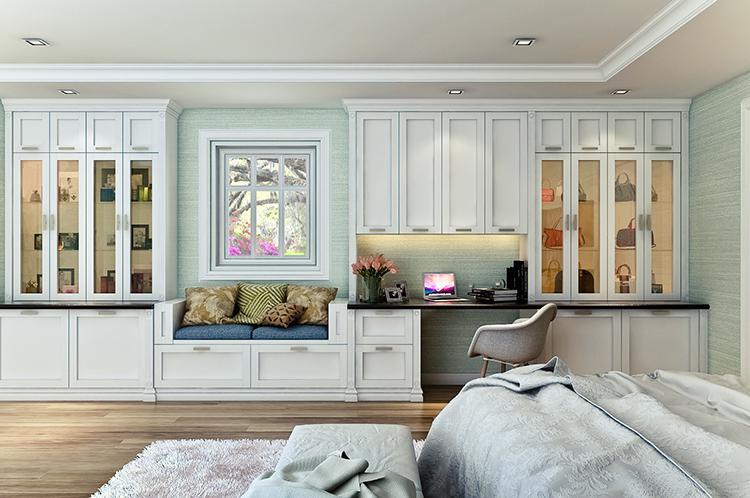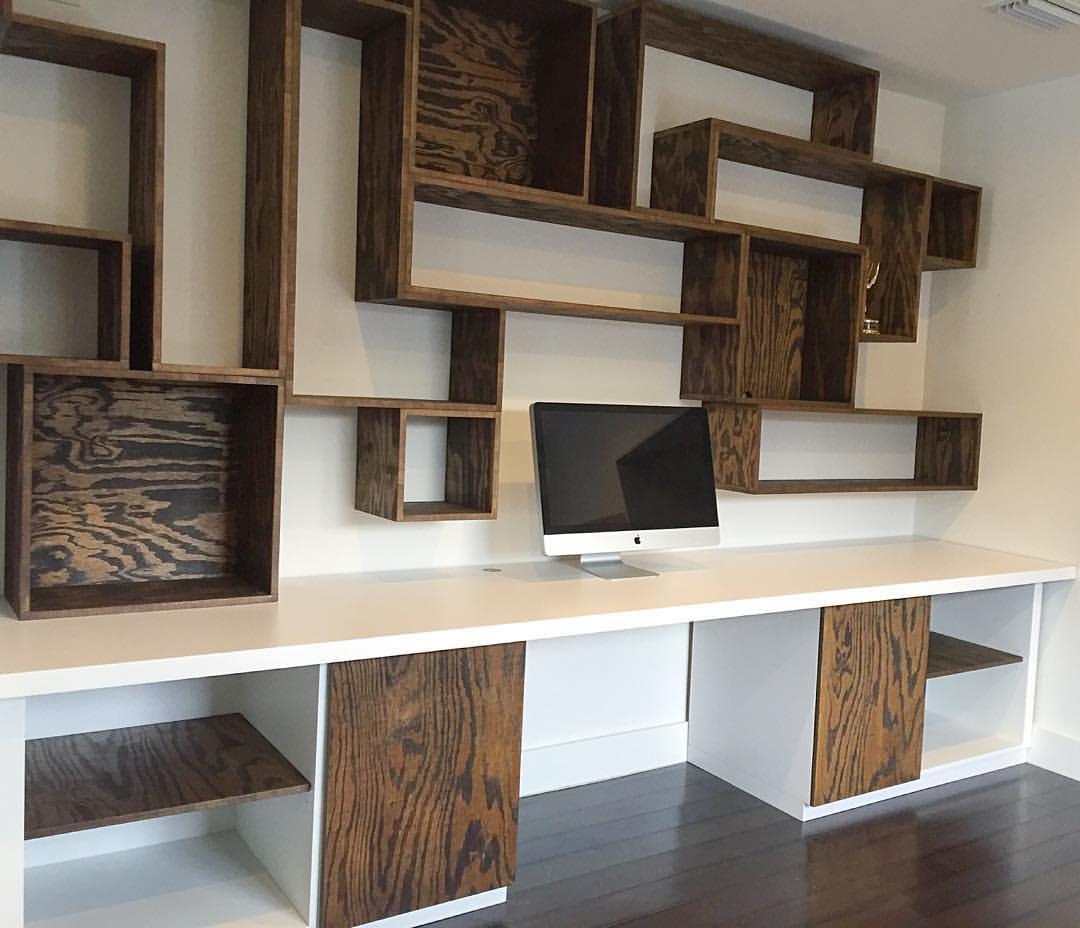The first image is the image on the left, the second image is the image on the right. For the images shown, is this caption "An image shows a desk topped with a monitor and coupled with brown shelves for books." true? Answer yes or no. Yes. The first image is the image on the left, the second image is the image on the right. Evaluate the accuracy of this statement regarding the images: "At least two woode chairs are by a computer desk.". Is it true? Answer yes or no. No. 